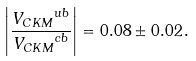Convert formula to latex. <formula><loc_0><loc_0><loc_500><loc_500>\left | \frac { { V _ { C K M } } ^ { u b } } { { V _ { C K M } } ^ { c b } } \right | = 0 . 0 8 \pm 0 . 0 2 \, .</formula> 